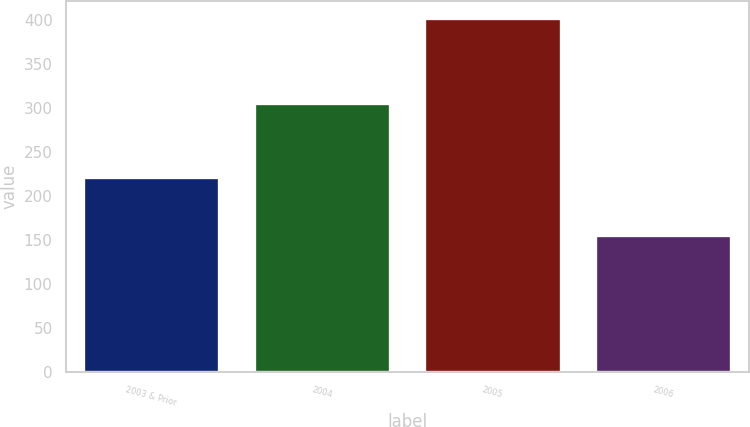<chart> <loc_0><loc_0><loc_500><loc_500><bar_chart><fcel>2003 & Prior<fcel>2004<fcel>2005<fcel>2006<nl><fcel>222<fcel>306<fcel>402<fcel>155<nl></chart> 